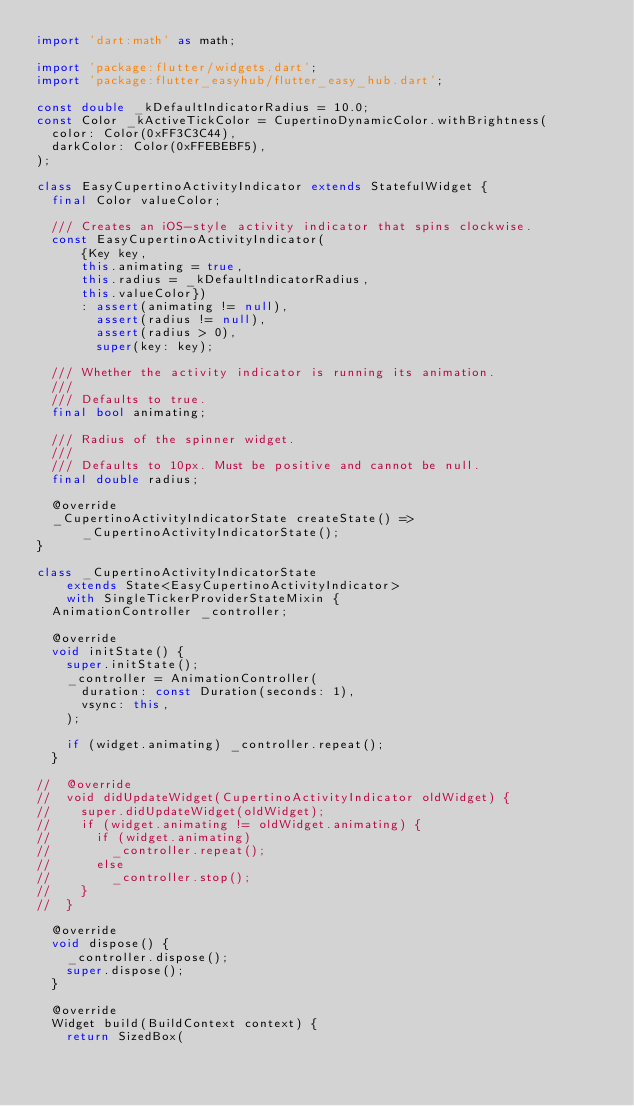<code> <loc_0><loc_0><loc_500><loc_500><_Dart_>import 'dart:math' as math;

import 'package:flutter/widgets.dart';
import 'package:flutter_easyhub/flutter_easy_hub.dart';

const double _kDefaultIndicatorRadius = 10.0;
const Color _kActiveTickColor = CupertinoDynamicColor.withBrightness(
  color: Color(0xFF3C3C44),
  darkColor: Color(0xFFEBEBF5),
);

class EasyCupertinoActivityIndicator extends StatefulWidget {
  final Color valueColor;

  /// Creates an iOS-style activity indicator that spins clockwise.
  const EasyCupertinoActivityIndicator(
      {Key key,
      this.animating = true,
      this.radius = _kDefaultIndicatorRadius,
      this.valueColor})
      : assert(animating != null),
        assert(radius != null),
        assert(radius > 0),
        super(key: key);

  /// Whether the activity indicator is running its animation.
  ///
  /// Defaults to true.
  final bool animating;

  /// Radius of the spinner widget.
  ///
  /// Defaults to 10px. Must be positive and cannot be null.
  final double radius;

  @override
  _CupertinoActivityIndicatorState createState() =>
      _CupertinoActivityIndicatorState();
}

class _CupertinoActivityIndicatorState
    extends State<EasyCupertinoActivityIndicator>
    with SingleTickerProviderStateMixin {
  AnimationController _controller;

  @override
  void initState() {
    super.initState();
    _controller = AnimationController(
      duration: const Duration(seconds: 1),
      vsync: this,
    );

    if (widget.animating) _controller.repeat();
  }

//  @override
//  void didUpdateWidget(CupertinoActivityIndicator oldWidget) {
//    super.didUpdateWidget(oldWidget);
//    if (widget.animating != oldWidget.animating) {
//      if (widget.animating)
//        _controller.repeat();
//      else
//        _controller.stop();
//    }
//  }

  @override
  void dispose() {
    _controller.dispose();
    super.dispose();
  }

  @override
  Widget build(BuildContext context) {
    return SizedBox(</code> 